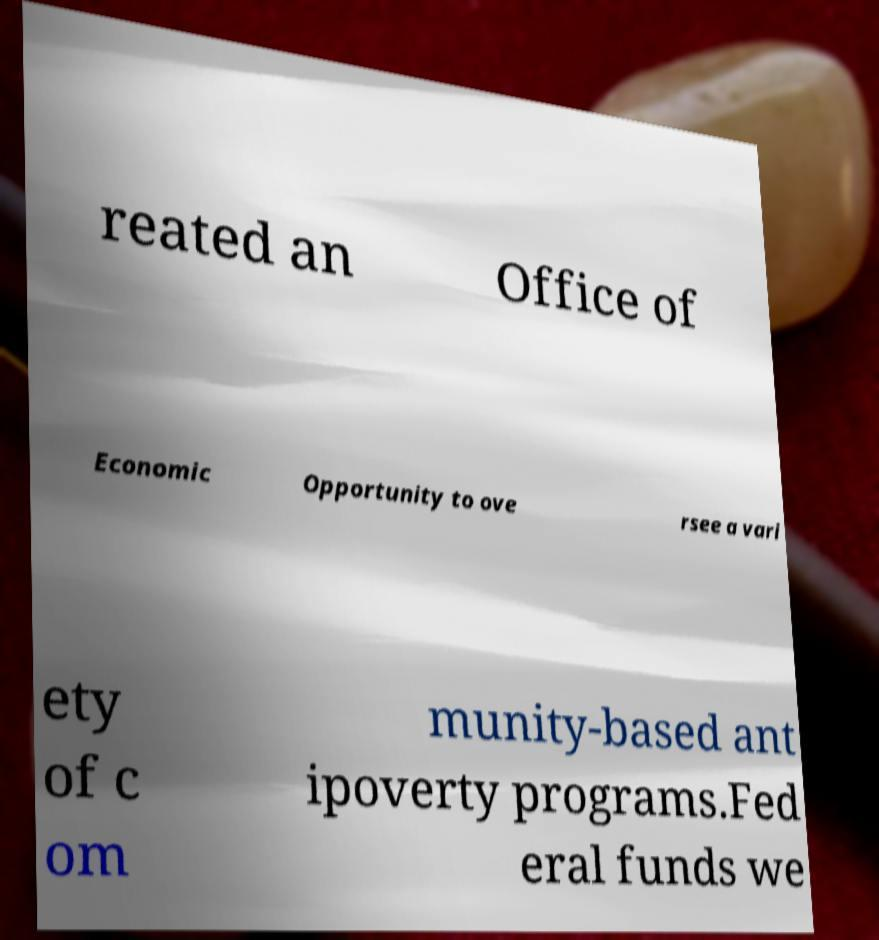I need the written content from this picture converted into text. Can you do that? reated an Office of Economic Opportunity to ove rsee a vari ety of c om munity-based ant ipoverty programs.Fed eral funds we 